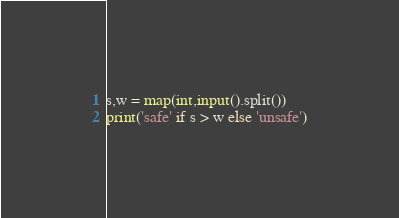<code> <loc_0><loc_0><loc_500><loc_500><_Python_>s,w = map(int,input().split())
print('safe' if s > w else 'unsafe')
</code> 